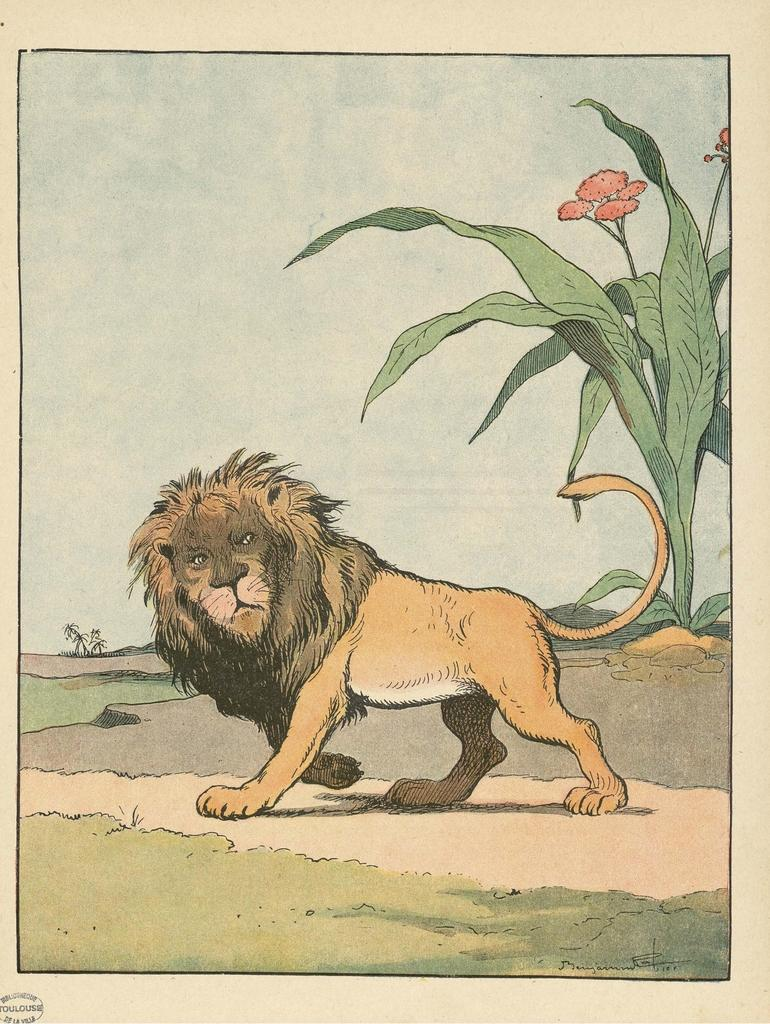What is present in the image that contains images and text? There is a poster in the image that contains images and text. Can you describe the location of the text on the poster? The text is located on the bottom left corner of the poster. What type of comfort can be seen being provided by the balls in the image? There are no balls present in the image, so comfort cannot be provided by them. 